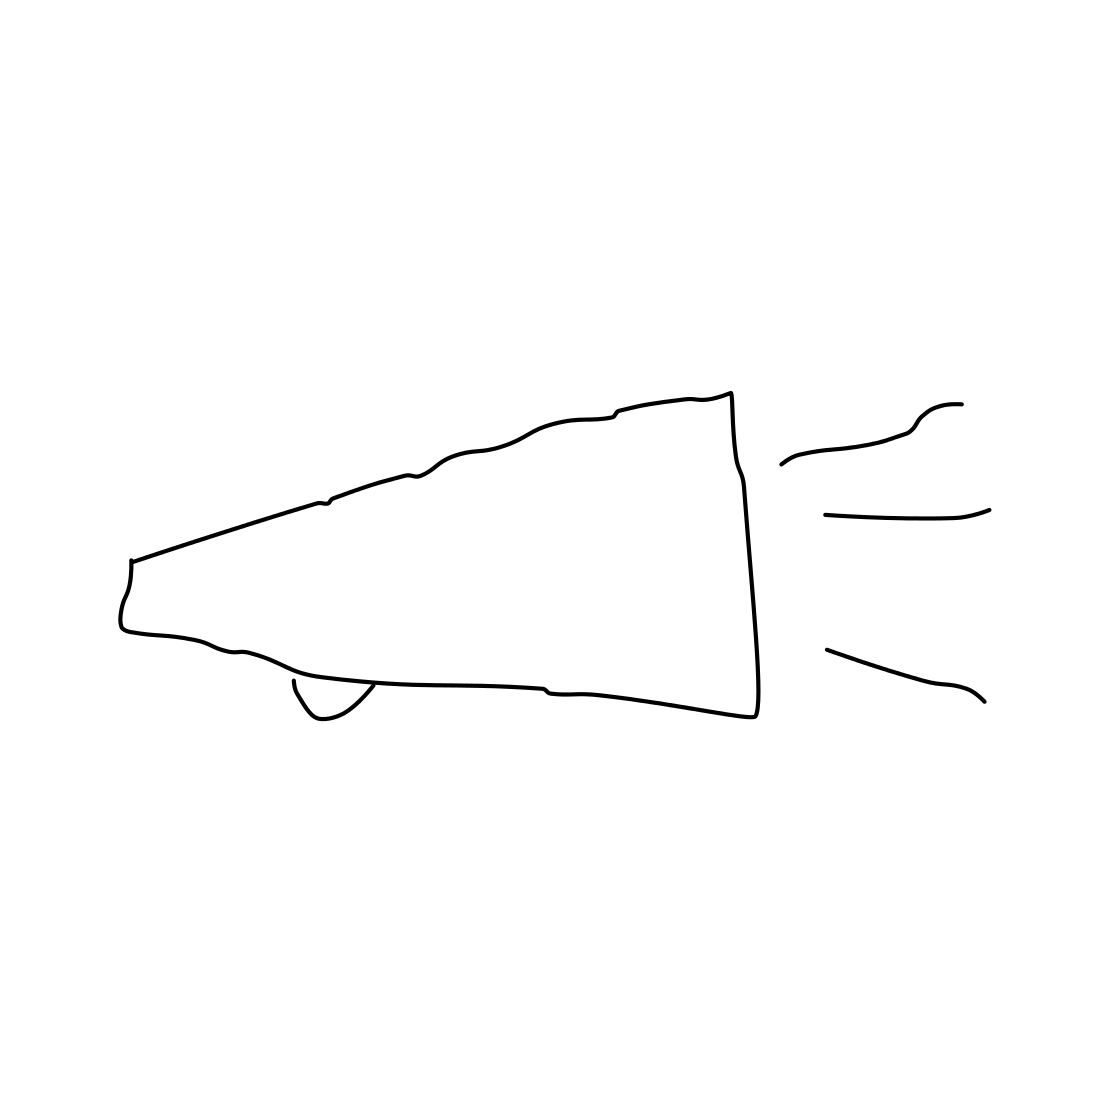Is there a sketchy megaphone in the picture? Indeed, the picture features a simplistic line drawing of a megaphone. Its outline is clear, and even though it's quite sketchy and lacks detail, the iconic shape with the bell, handle, and sound lines make it unmistakably a megaphone. 